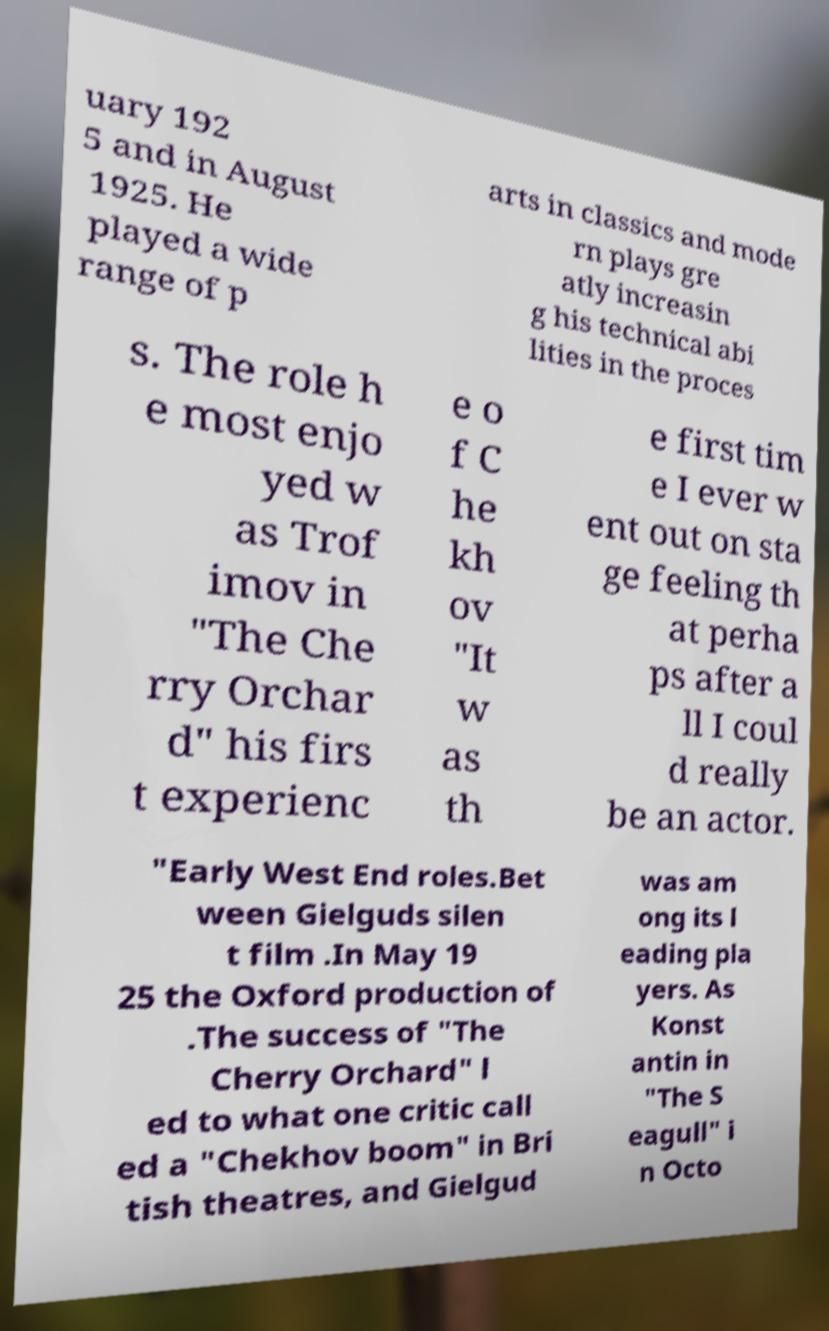Could you extract and type out the text from this image? uary 192 5 and in August 1925. He played a wide range of p arts in classics and mode rn plays gre atly increasin g his technical abi lities in the proces s. The role h e most enjo yed w as Trof imov in "The Che rry Orchar d" his firs t experienc e o f C he kh ov "It w as th e first tim e I ever w ent out on sta ge feeling th at perha ps after a ll I coul d really be an actor. "Early West End roles.Bet ween Gielguds silen t film .In May 19 25 the Oxford production of .The success of "The Cherry Orchard" l ed to what one critic call ed a "Chekhov boom" in Bri tish theatres, and Gielgud was am ong its l eading pla yers. As Konst antin in "The S eagull" i n Octo 